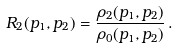Convert formula to latex. <formula><loc_0><loc_0><loc_500><loc_500>R _ { 2 } ( p _ { 1 } , p _ { 2 } ) = \frac { \rho _ { 2 } ( p _ { 1 } , p _ { 2 } ) } { \rho _ { 0 } ( p _ { 1 } , p _ { 2 } ) } \, .</formula> 